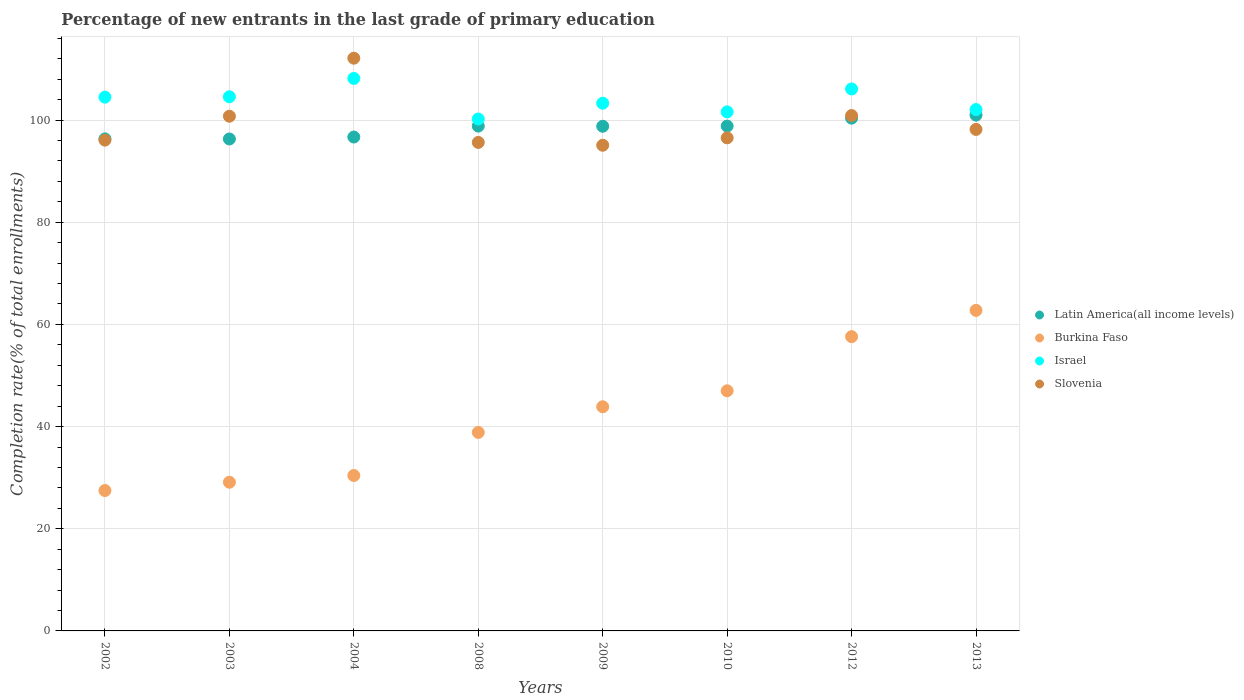Is the number of dotlines equal to the number of legend labels?
Your answer should be compact. Yes. What is the percentage of new entrants in Israel in 2009?
Provide a short and direct response. 103.29. Across all years, what is the maximum percentage of new entrants in Israel?
Provide a short and direct response. 108.15. Across all years, what is the minimum percentage of new entrants in Latin America(all income levels)?
Make the answer very short. 96.29. In which year was the percentage of new entrants in Israel maximum?
Provide a succinct answer. 2004. What is the total percentage of new entrants in Slovenia in the graph?
Give a very brief answer. 795.18. What is the difference between the percentage of new entrants in Latin America(all income levels) in 2009 and that in 2010?
Your answer should be compact. -0.04. What is the difference between the percentage of new entrants in Latin America(all income levels) in 2002 and the percentage of new entrants in Burkina Faso in 2003?
Offer a very short reply. 67.21. What is the average percentage of new entrants in Israel per year?
Provide a succinct answer. 103.8. In the year 2010, what is the difference between the percentage of new entrants in Slovenia and percentage of new entrants in Israel?
Offer a terse response. -5.08. What is the ratio of the percentage of new entrants in Israel in 2002 to that in 2003?
Offer a terse response. 1. Is the percentage of new entrants in Israel in 2002 less than that in 2003?
Provide a succinct answer. Yes. Is the difference between the percentage of new entrants in Slovenia in 2002 and 2004 greater than the difference between the percentage of new entrants in Israel in 2002 and 2004?
Give a very brief answer. No. What is the difference between the highest and the second highest percentage of new entrants in Burkina Faso?
Provide a short and direct response. 5.15. What is the difference between the highest and the lowest percentage of new entrants in Latin America(all income levels)?
Your answer should be compact. 4.67. In how many years, is the percentage of new entrants in Burkina Faso greater than the average percentage of new entrants in Burkina Faso taken over all years?
Make the answer very short. 4. Is the sum of the percentage of new entrants in Slovenia in 2004 and 2008 greater than the maximum percentage of new entrants in Latin America(all income levels) across all years?
Give a very brief answer. Yes. Is it the case that in every year, the sum of the percentage of new entrants in Slovenia and percentage of new entrants in Burkina Faso  is greater than the percentage of new entrants in Israel?
Provide a succinct answer. Yes. Does the percentage of new entrants in Israel monotonically increase over the years?
Offer a very short reply. No. What is the difference between two consecutive major ticks on the Y-axis?
Ensure brevity in your answer.  20. Are the values on the major ticks of Y-axis written in scientific E-notation?
Make the answer very short. No. Does the graph contain any zero values?
Offer a very short reply. No. Does the graph contain grids?
Your answer should be very brief. Yes. Where does the legend appear in the graph?
Give a very brief answer. Center right. What is the title of the graph?
Your answer should be compact. Percentage of new entrants in the last grade of primary education. What is the label or title of the X-axis?
Your response must be concise. Years. What is the label or title of the Y-axis?
Keep it short and to the point. Completion rate(% of total enrollments). What is the Completion rate(% of total enrollments) in Latin America(all income levels) in 2002?
Ensure brevity in your answer.  96.31. What is the Completion rate(% of total enrollments) of Burkina Faso in 2002?
Offer a very short reply. 27.48. What is the Completion rate(% of total enrollments) in Israel in 2002?
Your answer should be very brief. 104.48. What is the Completion rate(% of total enrollments) in Slovenia in 2002?
Your answer should be compact. 96.07. What is the Completion rate(% of total enrollments) in Latin America(all income levels) in 2003?
Your answer should be very brief. 96.29. What is the Completion rate(% of total enrollments) of Burkina Faso in 2003?
Keep it short and to the point. 29.11. What is the Completion rate(% of total enrollments) of Israel in 2003?
Your answer should be compact. 104.55. What is the Completion rate(% of total enrollments) in Slovenia in 2003?
Offer a very short reply. 100.75. What is the Completion rate(% of total enrollments) of Latin America(all income levels) in 2004?
Offer a very short reply. 96.68. What is the Completion rate(% of total enrollments) in Burkina Faso in 2004?
Ensure brevity in your answer.  30.42. What is the Completion rate(% of total enrollments) in Israel in 2004?
Provide a short and direct response. 108.15. What is the Completion rate(% of total enrollments) of Slovenia in 2004?
Your answer should be compact. 112.11. What is the Completion rate(% of total enrollments) in Latin America(all income levels) in 2008?
Offer a terse response. 98.81. What is the Completion rate(% of total enrollments) in Burkina Faso in 2008?
Give a very brief answer. 38.86. What is the Completion rate(% of total enrollments) in Israel in 2008?
Your answer should be very brief. 100.2. What is the Completion rate(% of total enrollments) of Slovenia in 2008?
Provide a succinct answer. 95.62. What is the Completion rate(% of total enrollments) in Latin America(all income levels) in 2009?
Ensure brevity in your answer.  98.78. What is the Completion rate(% of total enrollments) of Burkina Faso in 2009?
Ensure brevity in your answer.  43.88. What is the Completion rate(% of total enrollments) in Israel in 2009?
Your answer should be very brief. 103.29. What is the Completion rate(% of total enrollments) of Slovenia in 2009?
Provide a short and direct response. 95.07. What is the Completion rate(% of total enrollments) in Latin America(all income levels) in 2010?
Make the answer very short. 98.82. What is the Completion rate(% of total enrollments) of Burkina Faso in 2010?
Ensure brevity in your answer.  47. What is the Completion rate(% of total enrollments) in Israel in 2010?
Ensure brevity in your answer.  101.6. What is the Completion rate(% of total enrollments) in Slovenia in 2010?
Keep it short and to the point. 96.52. What is the Completion rate(% of total enrollments) of Latin America(all income levels) in 2012?
Provide a succinct answer. 100.37. What is the Completion rate(% of total enrollments) in Burkina Faso in 2012?
Keep it short and to the point. 57.6. What is the Completion rate(% of total enrollments) of Israel in 2012?
Your answer should be compact. 106.08. What is the Completion rate(% of total enrollments) of Slovenia in 2012?
Give a very brief answer. 100.88. What is the Completion rate(% of total enrollments) of Latin America(all income levels) in 2013?
Make the answer very short. 100.96. What is the Completion rate(% of total enrollments) in Burkina Faso in 2013?
Your answer should be compact. 62.75. What is the Completion rate(% of total enrollments) of Israel in 2013?
Ensure brevity in your answer.  102.05. What is the Completion rate(% of total enrollments) of Slovenia in 2013?
Your response must be concise. 98.17. Across all years, what is the maximum Completion rate(% of total enrollments) in Latin America(all income levels)?
Provide a short and direct response. 100.96. Across all years, what is the maximum Completion rate(% of total enrollments) in Burkina Faso?
Give a very brief answer. 62.75. Across all years, what is the maximum Completion rate(% of total enrollments) in Israel?
Provide a succinct answer. 108.15. Across all years, what is the maximum Completion rate(% of total enrollments) in Slovenia?
Offer a very short reply. 112.11. Across all years, what is the minimum Completion rate(% of total enrollments) of Latin America(all income levels)?
Your answer should be compact. 96.29. Across all years, what is the minimum Completion rate(% of total enrollments) of Burkina Faso?
Ensure brevity in your answer.  27.48. Across all years, what is the minimum Completion rate(% of total enrollments) of Israel?
Keep it short and to the point. 100.2. Across all years, what is the minimum Completion rate(% of total enrollments) of Slovenia?
Your answer should be compact. 95.07. What is the total Completion rate(% of total enrollments) of Latin America(all income levels) in the graph?
Provide a short and direct response. 787.03. What is the total Completion rate(% of total enrollments) of Burkina Faso in the graph?
Keep it short and to the point. 337.1. What is the total Completion rate(% of total enrollments) in Israel in the graph?
Give a very brief answer. 830.41. What is the total Completion rate(% of total enrollments) of Slovenia in the graph?
Your response must be concise. 795.18. What is the difference between the Completion rate(% of total enrollments) in Latin America(all income levels) in 2002 and that in 2003?
Your answer should be compact. 0.02. What is the difference between the Completion rate(% of total enrollments) in Burkina Faso in 2002 and that in 2003?
Make the answer very short. -1.62. What is the difference between the Completion rate(% of total enrollments) in Israel in 2002 and that in 2003?
Give a very brief answer. -0.07. What is the difference between the Completion rate(% of total enrollments) of Slovenia in 2002 and that in 2003?
Offer a very short reply. -4.68. What is the difference between the Completion rate(% of total enrollments) in Latin America(all income levels) in 2002 and that in 2004?
Provide a short and direct response. -0.36. What is the difference between the Completion rate(% of total enrollments) of Burkina Faso in 2002 and that in 2004?
Ensure brevity in your answer.  -2.94. What is the difference between the Completion rate(% of total enrollments) of Israel in 2002 and that in 2004?
Ensure brevity in your answer.  -3.66. What is the difference between the Completion rate(% of total enrollments) in Slovenia in 2002 and that in 2004?
Offer a very short reply. -16.04. What is the difference between the Completion rate(% of total enrollments) in Latin America(all income levels) in 2002 and that in 2008?
Ensure brevity in your answer.  -2.5. What is the difference between the Completion rate(% of total enrollments) of Burkina Faso in 2002 and that in 2008?
Your response must be concise. -11.38. What is the difference between the Completion rate(% of total enrollments) of Israel in 2002 and that in 2008?
Ensure brevity in your answer.  4.28. What is the difference between the Completion rate(% of total enrollments) in Slovenia in 2002 and that in 2008?
Your response must be concise. 0.45. What is the difference between the Completion rate(% of total enrollments) of Latin America(all income levels) in 2002 and that in 2009?
Keep it short and to the point. -2.47. What is the difference between the Completion rate(% of total enrollments) in Burkina Faso in 2002 and that in 2009?
Offer a very short reply. -16.4. What is the difference between the Completion rate(% of total enrollments) of Israel in 2002 and that in 2009?
Offer a very short reply. 1.19. What is the difference between the Completion rate(% of total enrollments) in Latin America(all income levels) in 2002 and that in 2010?
Your answer should be very brief. -2.51. What is the difference between the Completion rate(% of total enrollments) of Burkina Faso in 2002 and that in 2010?
Provide a succinct answer. -19.52. What is the difference between the Completion rate(% of total enrollments) of Israel in 2002 and that in 2010?
Your answer should be very brief. 2.89. What is the difference between the Completion rate(% of total enrollments) in Slovenia in 2002 and that in 2010?
Provide a short and direct response. -0.45. What is the difference between the Completion rate(% of total enrollments) in Latin America(all income levels) in 2002 and that in 2012?
Give a very brief answer. -4.06. What is the difference between the Completion rate(% of total enrollments) in Burkina Faso in 2002 and that in 2012?
Your answer should be compact. -30.12. What is the difference between the Completion rate(% of total enrollments) of Israel in 2002 and that in 2012?
Provide a succinct answer. -1.6. What is the difference between the Completion rate(% of total enrollments) in Slovenia in 2002 and that in 2012?
Offer a terse response. -4.81. What is the difference between the Completion rate(% of total enrollments) in Latin America(all income levels) in 2002 and that in 2013?
Offer a terse response. -4.65. What is the difference between the Completion rate(% of total enrollments) of Burkina Faso in 2002 and that in 2013?
Provide a short and direct response. -35.27. What is the difference between the Completion rate(% of total enrollments) in Israel in 2002 and that in 2013?
Offer a very short reply. 2.44. What is the difference between the Completion rate(% of total enrollments) in Slovenia in 2002 and that in 2013?
Make the answer very short. -2.1. What is the difference between the Completion rate(% of total enrollments) in Latin America(all income levels) in 2003 and that in 2004?
Keep it short and to the point. -0.38. What is the difference between the Completion rate(% of total enrollments) in Burkina Faso in 2003 and that in 2004?
Ensure brevity in your answer.  -1.31. What is the difference between the Completion rate(% of total enrollments) of Israel in 2003 and that in 2004?
Keep it short and to the point. -3.59. What is the difference between the Completion rate(% of total enrollments) in Slovenia in 2003 and that in 2004?
Keep it short and to the point. -11.36. What is the difference between the Completion rate(% of total enrollments) in Latin America(all income levels) in 2003 and that in 2008?
Provide a short and direct response. -2.52. What is the difference between the Completion rate(% of total enrollments) of Burkina Faso in 2003 and that in 2008?
Provide a short and direct response. -9.75. What is the difference between the Completion rate(% of total enrollments) of Israel in 2003 and that in 2008?
Provide a succinct answer. 4.35. What is the difference between the Completion rate(% of total enrollments) of Slovenia in 2003 and that in 2008?
Provide a succinct answer. 5.13. What is the difference between the Completion rate(% of total enrollments) of Latin America(all income levels) in 2003 and that in 2009?
Your answer should be very brief. -2.49. What is the difference between the Completion rate(% of total enrollments) of Burkina Faso in 2003 and that in 2009?
Provide a short and direct response. -14.77. What is the difference between the Completion rate(% of total enrollments) in Israel in 2003 and that in 2009?
Offer a very short reply. 1.26. What is the difference between the Completion rate(% of total enrollments) in Slovenia in 2003 and that in 2009?
Provide a succinct answer. 5.68. What is the difference between the Completion rate(% of total enrollments) of Latin America(all income levels) in 2003 and that in 2010?
Offer a very short reply. -2.52. What is the difference between the Completion rate(% of total enrollments) in Burkina Faso in 2003 and that in 2010?
Offer a terse response. -17.89. What is the difference between the Completion rate(% of total enrollments) of Israel in 2003 and that in 2010?
Keep it short and to the point. 2.96. What is the difference between the Completion rate(% of total enrollments) in Slovenia in 2003 and that in 2010?
Your response must be concise. 4.23. What is the difference between the Completion rate(% of total enrollments) in Latin America(all income levels) in 2003 and that in 2012?
Offer a very short reply. -4.08. What is the difference between the Completion rate(% of total enrollments) of Burkina Faso in 2003 and that in 2012?
Provide a short and direct response. -28.49. What is the difference between the Completion rate(% of total enrollments) of Israel in 2003 and that in 2012?
Make the answer very short. -1.53. What is the difference between the Completion rate(% of total enrollments) of Slovenia in 2003 and that in 2012?
Offer a terse response. -0.13. What is the difference between the Completion rate(% of total enrollments) of Latin America(all income levels) in 2003 and that in 2013?
Offer a terse response. -4.67. What is the difference between the Completion rate(% of total enrollments) of Burkina Faso in 2003 and that in 2013?
Give a very brief answer. -33.64. What is the difference between the Completion rate(% of total enrollments) of Israel in 2003 and that in 2013?
Keep it short and to the point. 2.51. What is the difference between the Completion rate(% of total enrollments) of Slovenia in 2003 and that in 2013?
Keep it short and to the point. 2.58. What is the difference between the Completion rate(% of total enrollments) in Latin America(all income levels) in 2004 and that in 2008?
Offer a very short reply. -2.14. What is the difference between the Completion rate(% of total enrollments) of Burkina Faso in 2004 and that in 2008?
Ensure brevity in your answer.  -8.44. What is the difference between the Completion rate(% of total enrollments) in Israel in 2004 and that in 2008?
Make the answer very short. 7.94. What is the difference between the Completion rate(% of total enrollments) in Slovenia in 2004 and that in 2008?
Provide a succinct answer. 16.49. What is the difference between the Completion rate(% of total enrollments) in Latin America(all income levels) in 2004 and that in 2009?
Your response must be concise. -2.11. What is the difference between the Completion rate(% of total enrollments) of Burkina Faso in 2004 and that in 2009?
Your answer should be very brief. -13.46. What is the difference between the Completion rate(% of total enrollments) of Israel in 2004 and that in 2009?
Offer a very short reply. 4.85. What is the difference between the Completion rate(% of total enrollments) of Slovenia in 2004 and that in 2009?
Your answer should be very brief. 17.04. What is the difference between the Completion rate(% of total enrollments) of Latin America(all income levels) in 2004 and that in 2010?
Offer a very short reply. -2.14. What is the difference between the Completion rate(% of total enrollments) of Burkina Faso in 2004 and that in 2010?
Give a very brief answer. -16.58. What is the difference between the Completion rate(% of total enrollments) of Israel in 2004 and that in 2010?
Provide a short and direct response. 6.55. What is the difference between the Completion rate(% of total enrollments) of Slovenia in 2004 and that in 2010?
Make the answer very short. 15.59. What is the difference between the Completion rate(% of total enrollments) in Latin America(all income levels) in 2004 and that in 2012?
Ensure brevity in your answer.  -3.7. What is the difference between the Completion rate(% of total enrollments) in Burkina Faso in 2004 and that in 2012?
Keep it short and to the point. -27.18. What is the difference between the Completion rate(% of total enrollments) of Israel in 2004 and that in 2012?
Provide a short and direct response. 2.06. What is the difference between the Completion rate(% of total enrollments) of Slovenia in 2004 and that in 2012?
Make the answer very short. 11.22. What is the difference between the Completion rate(% of total enrollments) in Latin America(all income levels) in 2004 and that in 2013?
Give a very brief answer. -4.29. What is the difference between the Completion rate(% of total enrollments) of Burkina Faso in 2004 and that in 2013?
Your answer should be compact. -32.33. What is the difference between the Completion rate(% of total enrollments) of Israel in 2004 and that in 2013?
Offer a terse response. 6.1. What is the difference between the Completion rate(% of total enrollments) in Slovenia in 2004 and that in 2013?
Your answer should be compact. 13.94. What is the difference between the Completion rate(% of total enrollments) of Latin America(all income levels) in 2008 and that in 2009?
Offer a very short reply. 0.03. What is the difference between the Completion rate(% of total enrollments) of Burkina Faso in 2008 and that in 2009?
Give a very brief answer. -5.02. What is the difference between the Completion rate(% of total enrollments) of Israel in 2008 and that in 2009?
Offer a terse response. -3.09. What is the difference between the Completion rate(% of total enrollments) in Slovenia in 2008 and that in 2009?
Make the answer very short. 0.55. What is the difference between the Completion rate(% of total enrollments) of Latin America(all income levels) in 2008 and that in 2010?
Your answer should be very brief. -0. What is the difference between the Completion rate(% of total enrollments) of Burkina Faso in 2008 and that in 2010?
Your answer should be very brief. -8.14. What is the difference between the Completion rate(% of total enrollments) in Israel in 2008 and that in 2010?
Your answer should be very brief. -1.39. What is the difference between the Completion rate(% of total enrollments) in Slovenia in 2008 and that in 2010?
Offer a very short reply. -0.89. What is the difference between the Completion rate(% of total enrollments) of Latin America(all income levels) in 2008 and that in 2012?
Make the answer very short. -1.56. What is the difference between the Completion rate(% of total enrollments) of Burkina Faso in 2008 and that in 2012?
Offer a very short reply. -18.74. What is the difference between the Completion rate(% of total enrollments) in Israel in 2008 and that in 2012?
Your response must be concise. -5.88. What is the difference between the Completion rate(% of total enrollments) of Slovenia in 2008 and that in 2012?
Your answer should be compact. -5.26. What is the difference between the Completion rate(% of total enrollments) of Latin America(all income levels) in 2008 and that in 2013?
Keep it short and to the point. -2.15. What is the difference between the Completion rate(% of total enrollments) of Burkina Faso in 2008 and that in 2013?
Offer a very short reply. -23.89. What is the difference between the Completion rate(% of total enrollments) of Israel in 2008 and that in 2013?
Offer a terse response. -1.84. What is the difference between the Completion rate(% of total enrollments) of Slovenia in 2008 and that in 2013?
Your answer should be very brief. -2.55. What is the difference between the Completion rate(% of total enrollments) in Latin America(all income levels) in 2009 and that in 2010?
Offer a terse response. -0.04. What is the difference between the Completion rate(% of total enrollments) in Burkina Faso in 2009 and that in 2010?
Offer a very short reply. -3.12. What is the difference between the Completion rate(% of total enrollments) in Israel in 2009 and that in 2010?
Your answer should be compact. 1.7. What is the difference between the Completion rate(% of total enrollments) in Slovenia in 2009 and that in 2010?
Give a very brief answer. -1.45. What is the difference between the Completion rate(% of total enrollments) of Latin America(all income levels) in 2009 and that in 2012?
Provide a succinct answer. -1.59. What is the difference between the Completion rate(% of total enrollments) in Burkina Faso in 2009 and that in 2012?
Keep it short and to the point. -13.72. What is the difference between the Completion rate(% of total enrollments) in Israel in 2009 and that in 2012?
Offer a terse response. -2.79. What is the difference between the Completion rate(% of total enrollments) of Slovenia in 2009 and that in 2012?
Your response must be concise. -5.81. What is the difference between the Completion rate(% of total enrollments) in Latin America(all income levels) in 2009 and that in 2013?
Ensure brevity in your answer.  -2.18. What is the difference between the Completion rate(% of total enrollments) of Burkina Faso in 2009 and that in 2013?
Your answer should be compact. -18.87. What is the difference between the Completion rate(% of total enrollments) of Israel in 2009 and that in 2013?
Your answer should be very brief. 1.25. What is the difference between the Completion rate(% of total enrollments) of Slovenia in 2009 and that in 2013?
Your response must be concise. -3.1. What is the difference between the Completion rate(% of total enrollments) in Latin America(all income levels) in 2010 and that in 2012?
Make the answer very short. -1.56. What is the difference between the Completion rate(% of total enrollments) of Israel in 2010 and that in 2012?
Offer a very short reply. -4.49. What is the difference between the Completion rate(% of total enrollments) of Slovenia in 2010 and that in 2012?
Provide a succinct answer. -4.37. What is the difference between the Completion rate(% of total enrollments) of Latin America(all income levels) in 2010 and that in 2013?
Your answer should be very brief. -2.14. What is the difference between the Completion rate(% of total enrollments) in Burkina Faso in 2010 and that in 2013?
Your answer should be very brief. -15.75. What is the difference between the Completion rate(% of total enrollments) of Israel in 2010 and that in 2013?
Your answer should be very brief. -0.45. What is the difference between the Completion rate(% of total enrollments) of Slovenia in 2010 and that in 2013?
Your answer should be compact. -1.65. What is the difference between the Completion rate(% of total enrollments) in Latin America(all income levels) in 2012 and that in 2013?
Your response must be concise. -0.59. What is the difference between the Completion rate(% of total enrollments) in Burkina Faso in 2012 and that in 2013?
Ensure brevity in your answer.  -5.15. What is the difference between the Completion rate(% of total enrollments) in Israel in 2012 and that in 2013?
Offer a terse response. 4.04. What is the difference between the Completion rate(% of total enrollments) of Slovenia in 2012 and that in 2013?
Your answer should be compact. 2.71. What is the difference between the Completion rate(% of total enrollments) of Latin America(all income levels) in 2002 and the Completion rate(% of total enrollments) of Burkina Faso in 2003?
Give a very brief answer. 67.21. What is the difference between the Completion rate(% of total enrollments) of Latin America(all income levels) in 2002 and the Completion rate(% of total enrollments) of Israel in 2003?
Ensure brevity in your answer.  -8.24. What is the difference between the Completion rate(% of total enrollments) of Latin America(all income levels) in 2002 and the Completion rate(% of total enrollments) of Slovenia in 2003?
Your answer should be very brief. -4.44. What is the difference between the Completion rate(% of total enrollments) of Burkina Faso in 2002 and the Completion rate(% of total enrollments) of Israel in 2003?
Offer a very short reply. -77.07. What is the difference between the Completion rate(% of total enrollments) in Burkina Faso in 2002 and the Completion rate(% of total enrollments) in Slovenia in 2003?
Keep it short and to the point. -73.26. What is the difference between the Completion rate(% of total enrollments) of Israel in 2002 and the Completion rate(% of total enrollments) of Slovenia in 2003?
Your answer should be very brief. 3.74. What is the difference between the Completion rate(% of total enrollments) in Latin America(all income levels) in 2002 and the Completion rate(% of total enrollments) in Burkina Faso in 2004?
Provide a succinct answer. 65.89. What is the difference between the Completion rate(% of total enrollments) in Latin America(all income levels) in 2002 and the Completion rate(% of total enrollments) in Israel in 2004?
Make the answer very short. -11.83. What is the difference between the Completion rate(% of total enrollments) in Latin America(all income levels) in 2002 and the Completion rate(% of total enrollments) in Slovenia in 2004?
Your answer should be compact. -15.79. What is the difference between the Completion rate(% of total enrollments) in Burkina Faso in 2002 and the Completion rate(% of total enrollments) in Israel in 2004?
Offer a very short reply. -80.66. What is the difference between the Completion rate(% of total enrollments) of Burkina Faso in 2002 and the Completion rate(% of total enrollments) of Slovenia in 2004?
Provide a succinct answer. -84.62. What is the difference between the Completion rate(% of total enrollments) of Israel in 2002 and the Completion rate(% of total enrollments) of Slovenia in 2004?
Provide a short and direct response. -7.62. What is the difference between the Completion rate(% of total enrollments) in Latin America(all income levels) in 2002 and the Completion rate(% of total enrollments) in Burkina Faso in 2008?
Your answer should be compact. 57.45. What is the difference between the Completion rate(% of total enrollments) of Latin America(all income levels) in 2002 and the Completion rate(% of total enrollments) of Israel in 2008?
Ensure brevity in your answer.  -3.89. What is the difference between the Completion rate(% of total enrollments) of Latin America(all income levels) in 2002 and the Completion rate(% of total enrollments) of Slovenia in 2008?
Your response must be concise. 0.69. What is the difference between the Completion rate(% of total enrollments) of Burkina Faso in 2002 and the Completion rate(% of total enrollments) of Israel in 2008?
Ensure brevity in your answer.  -72.72. What is the difference between the Completion rate(% of total enrollments) of Burkina Faso in 2002 and the Completion rate(% of total enrollments) of Slovenia in 2008?
Give a very brief answer. -68.14. What is the difference between the Completion rate(% of total enrollments) in Israel in 2002 and the Completion rate(% of total enrollments) in Slovenia in 2008?
Provide a short and direct response. 8.86. What is the difference between the Completion rate(% of total enrollments) of Latin America(all income levels) in 2002 and the Completion rate(% of total enrollments) of Burkina Faso in 2009?
Your response must be concise. 52.43. What is the difference between the Completion rate(% of total enrollments) in Latin America(all income levels) in 2002 and the Completion rate(% of total enrollments) in Israel in 2009?
Offer a terse response. -6.98. What is the difference between the Completion rate(% of total enrollments) in Latin America(all income levels) in 2002 and the Completion rate(% of total enrollments) in Slovenia in 2009?
Ensure brevity in your answer.  1.24. What is the difference between the Completion rate(% of total enrollments) of Burkina Faso in 2002 and the Completion rate(% of total enrollments) of Israel in 2009?
Offer a very short reply. -75.81. What is the difference between the Completion rate(% of total enrollments) in Burkina Faso in 2002 and the Completion rate(% of total enrollments) in Slovenia in 2009?
Ensure brevity in your answer.  -67.58. What is the difference between the Completion rate(% of total enrollments) of Israel in 2002 and the Completion rate(% of total enrollments) of Slovenia in 2009?
Provide a short and direct response. 9.42. What is the difference between the Completion rate(% of total enrollments) in Latin America(all income levels) in 2002 and the Completion rate(% of total enrollments) in Burkina Faso in 2010?
Keep it short and to the point. 49.31. What is the difference between the Completion rate(% of total enrollments) in Latin America(all income levels) in 2002 and the Completion rate(% of total enrollments) in Israel in 2010?
Provide a succinct answer. -5.28. What is the difference between the Completion rate(% of total enrollments) in Latin America(all income levels) in 2002 and the Completion rate(% of total enrollments) in Slovenia in 2010?
Provide a short and direct response. -0.2. What is the difference between the Completion rate(% of total enrollments) of Burkina Faso in 2002 and the Completion rate(% of total enrollments) of Israel in 2010?
Offer a very short reply. -74.11. What is the difference between the Completion rate(% of total enrollments) in Burkina Faso in 2002 and the Completion rate(% of total enrollments) in Slovenia in 2010?
Offer a terse response. -69.03. What is the difference between the Completion rate(% of total enrollments) in Israel in 2002 and the Completion rate(% of total enrollments) in Slovenia in 2010?
Your answer should be compact. 7.97. What is the difference between the Completion rate(% of total enrollments) of Latin America(all income levels) in 2002 and the Completion rate(% of total enrollments) of Burkina Faso in 2012?
Your answer should be compact. 38.71. What is the difference between the Completion rate(% of total enrollments) in Latin America(all income levels) in 2002 and the Completion rate(% of total enrollments) in Israel in 2012?
Keep it short and to the point. -9.77. What is the difference between the Completion rate(% of total enrollments) in Latin America(all income levels) in 2002 and the Completion rate(% of total enrollments) in Slovenia in 2012?
Provide a short and direct response. -4.57. What is the difference between the Completion rate(% of total enrollments) in Burkina Faso in 2002 and the Completion rate(% of total enrollments) in Israel in 2012?
Offer a terse response. -78.6. What is the difference between the Completion rate(% of total enrollments) of Burkina Faso in 2002 and the Completion rate(% of total enrollments) of Slovenia in 2012?
Keep it short and to the point. -73.4. What is the difference between the Completion rate(% of total enrollments) in Israel in 2002 and the Completion rate(% of total enrollments) in Slovenia in 2012?
Your response must be concise. 3.6. What is the difference between the Completion rate(% of total enrollments) of Latin America(all income levels) in 2002 and the Completion rate(% of total enrollments) of Burkina Faso in 2013?
Make the answer very short. 33.56. What is the difference between the Completion rate(% of total enrollments) in Latin America(all income levels) in 2002 and the Completion rate(% of total enrollments) in Israel in 2013?
Your answer should be compact. -5.73. What is the difference between the Completion rate(% of total enrollments) of Latin America(all income levels) in 2002 and the Completion rate(% of total enrollments) of Slovenia in 2013?
Ensure brevity in your answer.  -1.86. What is the difference between the Completion rate(% of total enrollments) of Burkina Faso in 2002 and the Completion rate(% of total enrollments) of Israel in 2013?
Offer a terse response. -74.56. What is the difference between the Completion rate(% of total enrollments) of Burkina Faso in 2002 and the Completion rate(% of total enrollments) of Slovenia in 2013?
Your answer should be very brief. -70.69. What is the difference between the Completion rate(% of total enrollments) in Israel in 2002 and the Completion rate(% of total enrollments) in Slovenia in 2013?
Your answer should be very brief. 6.32. What is the difference between the Completion rate(% of total enrollments) in Latin America(all income levels) in 2003 and the Completion rate(% of total enrollments) in Burkina Faso in 2004?
Provide a short and direct response. 65.87. What is the difference between the Completion rate(% of total enrollments) of Latin America(all income levels) in 2003 and the Completion rate(% of total enrollments) of Israel in 2004?
Your answer should be very brief. -11.85. What is the difference between the Completion rate(% of total enrollments) in Latin America(all income levels) in 2003 and the Completion rate(% of total enrollments) in Slovenia in 2004?
Provide a succinct answer. -15.81. What is the difference between the Completion rate(% of total enrollments) in Burkina Faso in 2003 and the Completion rate(% of total enrollments) in Israel in 2004?
Your response must be concise. -79.04. What is the difference between the Completion rate(% of total enrollments) of Burkina Faso in 2003 and the Completion rate(% of total enrollments) of Slovenia in 2004?
Provide a succinct answer. -83. What is the difference between the Completion rate(% of total enrollments) of Israel in 2003 and the Completion rate(% of total enrollments) of Slovenia in 2004?
Your answer should be very brief. -7.55. What is the difference between the Completion rate(% of total enrollments) of Latin America(all income levels) in 2003 and the Completion rate(% of total enrollments) of Burkina Faso in 2008?
Give a very brief answer. 57.44. What is the difference between the Completion rate(% of total enrollments) in Latin America(all income levels) in 2003 and the Completion rate(% of total enrollments) in Israel in 2008?
Offer a terse response. -3.91. What is the difference between the Completion rate(% of total enrollments) of Latin America(all income levels) in 2003 and the Completion rate(% of total enrollments) of Slovenia in 2008?
Make the answer very short. 0.67. What is the difference between the Completion rate(% of total enrollments) of Burkina Faso in 2003 and the Completion rate(% of total enrollments) of Israel in 2008?
Offer a terse response. -71.1. What is the difference between the Completion rate(% of total enrollments) in Burkina Faso in 2003 and the Completion rate(% of total enrollments) in Slovenia in 2008?
Keep it short and to the point. -66.51. What is the difference between the Completion rate(% of total enrollments) of Israel in 2003 and the Completion rate(% of total enrollments) of Slovenia in 2008?
Provide a succinct answer. 8.93. What is the difference between the Completion rate(% of total enrollments) of Latin America(all income levels) in 2003 and the Completion rate(% of total enrollments) of Burkina Faso in 2009?
Your answer should be very brief. 52.41. What is the difference between the Completion rate(% of total enrollments) of Latin America(all income levels) in 2003 and the Completion rate(% of total enrollments) of Israel in 2009?
Your answer should be compact. -7. What is the difference between the Completion rate(% of total enrollments) of Latin America(all income levels) in 2003 and the Completion rate(% of total enrollments) of Slovenia in 2009?
Offer a terse response. 1.23. What is the difference between the Completion rate(% of total enrollments) in Burkina Faso in 2003 and the Completion rate(% of total enrollments) in Israel in 2009?
Keep it short and to the point. -74.19. What is the difference between the Completion rate(% of total enrollments) in Burkina Faso in 2003 and the Completion rate(% of total enrollments) in Slovenia in 2009?
Provide a short and direct response. -65.96. What is the difference between the Completion rate(% of total enrollments) in Israel in 2003 and the Completion rate(% of total enrollments) in Slovenia in 2009?
Give a very brief answer. 9.49. What is the difference between the Completion rate(% of total enrollments) in Latin America(all income levels) in 2003 and the Completion rate(% of total enrollments) in Burkina Faso in 2010?
Offer a very short reply. 49.29. What is the difference between the Completion rate(% of total enrollments) of Latin America(all income levels) in 2003 and the Completion rate(% of total enrollments) of Israel in 2010?
Keep it short and to the point. -5.3. What is the difference between the Completion rate(% of total enrollments) of Latin America(all income levels) in 2003 and the Completion rate(% of total enrollments) of Slovenia in 2010?
Give a very brief answer. -0.22. What is the difference between the Completion rate(% of total enrollments) of Burkina Faso in 2003 and the Completion rate(% of total enrollments) of Israel in 2010?
Give a very brief answer. -72.49. What is the difference between the Completion rate(% of total enrollments) in Burkina Faso in 2003 and the Completion rate(% of total enrollments) in Slovenia in 2010?
Your answer should be compact. -67.41. What is the difference between the Completion rate(% of total enrollments) in Israel in 2003 and the Completion rate(% of total enrollments) in Slovenia in 2010?
Give a very brief answer. 8.04. What is the difference between the Completion rate(% of total enrollments) of Latin America(all income levels) in 2003 and the Completion rate(% of total enrollments) of Burkina Faso in 2012?
Give a very brief answer. 38.69. What is the difference between the Completion rate(% of total enrollments) of Latin America(all income levels) in 2003 and the Completion rate(% of total enrollments) of Israel in 2012?
Make the answer very short. -9.79. What is the difference between the Completion rate(% of total enrollments) of Latin America(all income levels) in 2003 and the Completion rate(% of total enrollments) of Slovenia in 2012?
Give a very brief answer. -4.59. What is the difference between the Completion rate(% of total enrollments) in Burkina Faso in 2003 and the Completion rate(% of total enrollments) in Israel in 2012?
Provide a short and direct response. -76.98. What is the difference between the Completion rate(% of total enrollments) of Burkina Faso in 2003 and the Completion rate(% of total enrollments) of Slovenia in 2012?
Your answer should be compact. -71.78. What is the difference between the Completion rate(% of total enrollments) in Israel in 2003 and the Completion rate(% of total enrollments) in Slovenia in 2012?
Provide a short and direct response. 3.67. What is the difference between the Completion rate(% of total enrollments) in Latin America(all income levels) in 2003 and the Completion rate(% of total enrollments) in Burkina Faso in 2013?
Provide a succinct answer. 33.55. What is the difference between the Completion rate(% of total enrollments) of Latin America(all income levels) in 2003 and the Completion rate(% of total enrollments) of Israel in 2013?
Keep it short and to the point. -5.75. What is the difference between the Completion rate(% of total enrollments) of Latin America(all income levels) in 2003 and the Completion rate(% of total enrollments) of Slovenia in 2013?
Keep it short and to the point. -1.88. What is the difference between the Completion rate(% of total enrollments) in Burkina Faso in 2003 and the Completion rate(% of total enrollments) in Israel in 2013?
Offer a terse response. -72.94. What is the difference between the Completion rate(% of total enrollments) in Burkina Faso in 2003 and the Completion rate(% of total enrollments) in Slovenia in 2013?
Provide a short and direct response. -69.06. What is the difference between the Completion rate(% of total enrollments) in Israel in 2003 and the Completion rate(% of total enrollments) in Slovenia in 2013?
Provide a short and direct response. 6.39. What is the difference between the Completion rate(% of total enrollments) in Latin America(all income levels) in 2004 and the Completion rate(% of total enrollments) in Burkina Faso in 2008?
Your response must be concise. 57.82. What is the difference between the Completion rate(% of total enrollments) of Latin America(all income levels) in 2004 and the Completion rate(% of total enrollments) of Israel in 2008?
Offer a very short reply. -3.53. What is the difference between the Completion rate(% of total enrollments) of Latin America(all income levels) in 2004 and the Completion rate(% of total enrollments) of Slovenia in 2008?
Make the answer very short. 1.05. What is the difference between the Completion rate(% of total enrollments) in Burkina Faso in 2004 and the Completion rate(% of total enrollments) in Israel in 2008?
Make the answer very short. -69.78. What is the difference between the Completion rate(% of total enrollments) of Burkina Faso in 2004 and the Completion rate(% of total enrollments) of Slovenia in 2008?
Your response must be concise. -65.2. What is the difference between the Completion rate(% of total enrollments) of Israel in 2004 and the Completion rate(% of total enrollments) of Slovenia in 2008?
Offer a terse response. 12.52. What is the difference between the Completion rate(% of total enrollments) in Latin America(all income levels) in 2004 and the Completion rate(% of total enrollments) in Burkina Faso in 2009?
Make the answer very short. 52.8. What is the difference between the Completion rate(% of total enrollments) in Latin America(all income levels) in 2004 and the Completion rate(% of total enrollments) in Israel in 2009?
Make the answer very short. -6.62. What is the difference between the Completion rate(% of total enrollments) of Latin America(all income levels) in 2004 and the Completion rate(% of total enrollments) of Slovenia in 2009?
Make the answer very short. 1.61. What is the difference between the Completion rate(% of total enrollments) in Burkina Faso in 2004 and the Completion rate(% of total enrollments) in Israel in 2009?
Give a very brief answer. -72.87. What is the difference between the Completion rate(% of total enrollments) in Burkina Faso in 2004 and the Completion rate(% of total enrollments) in Slovenia in 2009?
Provide a succinct answer. -64.65. What is the difference between the Completion rate(% of total enrollments) in Israel in 2004 and the Completion rate(% of total enrollments) in Slovenia in 2009?
Give a very brief answer. 13.08. What is the difference between the Completion rate(% of total enrollments) of Latin America(all income levels) in 2004 and the Completion rate(% of total enrollments) of Burkina Faso in 2010?
Ensure brevity in your answer.  49.67. What is the difference between the Completion rate(% of total enrollments) in Latin America(all income levels) in 2004 and the Completion rate(% of total enrollments) in Israel in 2010?
Give a very brief answer. -4.92. What is the difference between the Completion rate(% of total enrollments) in Latin America(all income levels) in 2004 and the Completion rate(% of total enrollments) in Slovenia in 2010?
Your answer should be very brief. 0.16. What is the difference between the Completion rate(% of total enrollments) of Burkina Faso in 2004 and the Completion rate(% of total enrollments) of Israel in 2010?
Ensure brevity in your answer.  -71.18. What is the difference between the Completion rate(% of total enrollments) in Burkina Faso in 2004 and the Completion rate(% of total enrollments) in Slovenia in 2010?
Provide a succinct answer. -66.09. What is the difference between the Completion rate(% of total enrollments) of Israel in 2004 and the Completion rate(% of total enrollments) of Slovenia in 2010?
Ensure brevity in your answer.  11.63. What is the difference between the Completion rate(% of total enrollments) in Latin America(all income levels) in 2004 and the Completion rate(% of total enrollments) in Burkina Faso in 2012?
Give a very brief answer. 39.07. What is the difference between the Completion rate(% of total enrollments) in Latin America(all income levels) in 2004 and the Completion rate(% of total enrollments) in Israel in 2012?
Offer a terse response. -9.41. What is the difference between the Completion rate(% of total enrollments) in Latin America(all income levels) in 2004 and the Completion rate(% of total enrollments) in Slovenia in 2012?
Offer a very short reply. -4.21. What is the difference between the Completion rate(% of total enrollments) in Burkina Faso in 2004 and the Completion rate(% of total enrollments) in Israel in 2012?
Your answer should be compact. -75.66. What is the difference between the Completion rate(% of total enrollments) in Burkina Faso in 2004 and the Completion rate(% of total enrollments) in Slovenia in 2012?
Provide a succinct answer. -70.46. What is the difference between the Completion rate(% of total enrollments) of Israel in 2004 and the Completion rate(% of total enrollments) of Slovenia in 2012?
Provide a succinct answer. 7.26. What is the difference between the Completion rate(% of total enrollments) in Latin America(all income levels) in 2004 and the Completion rate(% of total enrollments) in Burkina Faso in 2013?
Keep it short and to the point. 33.93. What is the difference between the Completion rate(% of total enrollments) of Latin America(all income levels) in 2004 and the Completion rate(% of total enrollments) of Israel in 2013?
Offer a terse response. -5.37. What is the difference between the Completion rate(% of total enrollments) of Latin America(all income levels) in 2004 and the Completion rate(% of total enrollments) of Slovenia in 2013?
Offer a very short reply. -1.49. What is the difference between the Completion rate(% of total enrollments) of Burkina Faso in 2004 and the Completion rate(% of total enrollments) of Israel in 2013?
Give a very brief answer. -71.63. What is the difference between the Completion rate(% of total enrollments) of Burkina Faso in 2004 and the Completion rate(% of total enrollments) of Slovenia in 2013?
Ensure brevity in your answer.  -67.75. What is the difference between the Completion rate(% of total enrollments) in Israel in 2004 and the Completion rate(% of total enrollments) in Slovenia in 2013?
Give a very brief answer. 9.98. What is the difference between the Completion rate(% of total enrollments) of Latin America(all income levels) in 2008 and the Completion rate(% of total enrollments) of Burkina Faso in 2009?
Your response must be concise. 54.93. What is the difference between the Completion rate(% of total enrollments) in Latin America(all income levels) in 2008 and the Completion rate(% of total enrollments) in Israel in 2009?
Keep it short and to the point. -4.48. What is the difference between the Completion rate(% of total enrollments) in Latin America(all income levels) in 2008 and the Completion rate(% of total enrollments) in Slovenia in 2009?
Make the answer very short. 3.75. What is the difference between the Completion rate(% of total enrollments) in Burkina Faso in 2008 and the Completion rate(% of total enrollments) in Israel in 2009?
Give a very brief answer. -64.43. What is the difference between the Completion rate(% of total enrollments) of Burkina Faso in 2008 and the Completion rate(% of total enrollments) of Slovenia in 2009?
Your answer should be very brief. -56.21. What is the difference between the Completion rate(% of total enrollments) in Israel in 2008 and the Completion rate(% of total enrollments) in Slovenia in 2009?
Offer a terse response. 5.14. What is the difference between the Completion rate(% of total enrollments) in Latin America(all income levels) in 2008 and the Completion rate(% of total enrollments) in Burkina Faso in 2010?
Provide a succinct answer. 51.81. What is the difference between the Completion rate(% of total enrollments) of Latin America(all income levels) in 2008 and the Completion rate(% of total enrollments) of Israel in 2010?
Offer a terse response. -2.78. What is the difference between the Completion rate(% of total enrollments) of Latin America(all income levels) in 2008 and the Completion rate(% of total enrollments) of Slovenia in 2010?
Your answer should be very brief. 2.3. What is the difference between the Completion rate(% of total enrollments) in Burkina Faso in 2008 and the Completion rate(% of total enrollments) in Israel in 2010?
Ensure brevity in your answer.  -62.74. What is the difference between the Completion rate(% of total enrollments) in Burkina Faso in 2008 and the Completion rate(% of total enrollments) in Slovenia in 2010?
Your answer should be very brief. -57.66. What is the difference between the Completion rate(% of total enrollments) in Israel in 2008 and the Completion rate(% of total enrollments) in Slovenia in 2010?
Ensure brevity in your answer.  3.69. What is the difference between the Completion rate(% of total enrollments) of Latin America(all income levels) in 2008 and the Completion rate(% of total enrollments) of Burkina Faso in 2012?
Provide a short and direct response. 41.21. What is the difference between the Completion rate(% of total enrollments) in Latin America(all income levels) in 2008 and the Completion rate(% of total enrollments) in Israel in 2012?
Offer a very short reply. -7.27. What is the difference between the Completion rate(% of total enrollments) of Latin America(all income levels) in 2008 and the Completion rate(% of total enrollments) of Slovenia in 2012?
Provide a succinct answer. -2.07. What is the difference between the Completion rate(% of total enrollments) of Burkina Faso in 2008 and the Completion rate(% of total enrollments) of Israel in 2012?
Your response must be concise. -67.23. What is the difference between the Completion rate(% of total enrollments) of Burkina Faso in 2008 and the Completion rate(% of total enrollments) of Slovenia in 2012?
Keep it short and to the point. -62.02. What is the difference between the Completion rate(% of total enrollments) of Israel in 2008 and the Completion rate(% of total enrollments) of Slovenia in 2012?
Keep it short and to the point. -0.68. What is the difference between the Completion rate(% of total enrollments) of Latin America(all income levels) in 2008 and the Completion rate(% of total enrollments) of Burkina Faso in 2013?
Make the answer very short. 36.07. What is the difference between the Completion rate(% of total enrollments) in Latin America(all income levels) in 2008 and the Completion rate(% of total enrollments) in Israel in 2013?
Provide a succinct answer. -3.23. What is the difference between the Completion rate(% of total enrollments) of Latin America(all income levels) in 2008 and the Completion rate(% of total enrollments) of Slovenia in 2013?
Give a very brief answer. 0.65. What is the difference between the Completion rate(% of total enrollments) in Burkina Faso in 2008 and the Completion rate(% of total enrollments) in Israel in 2013?
Your response must be concise. -63.19. What is the difference between the Completion rate(% of total enrollments) in Burkina Faso in 2008 and the Completion rate(% of total enrollments) in Slovenia in 2013?
Your answer should be very brief. -59.31. What is the difference between the Completion rate(% of total enrollments) in Israel in 2008 and the Completion rate(% of total enrollments) in Slovenia in 2013?
Offer a very short reply. 2.03. What is the difference between the Completion rate(% of total enrollments) of Latin America(all income levels) in 2009 and the Completion rate(% of total enrollments) of Burkina Faso in 2010?
Keep it short and to the point. 51.78. What is the difference between the Completion rate(% of total enrollments) in Latin America(all income levels) in 2009 and the Completion rate(% of total enrollments) in Israel in 2010?
Offer a terse response. -2.82. What is the difference between the Completion rate(% of total enrollments) of Latin America(all income levels) in 2009 and the Completion rate(% of total enrollments) of Slovenia in 2010?
Give a very brief answer. 2.27. What is the difference between the Completion rate(% of total enrollments) of Burkina Faso in 2009 and the Completion rate(% of total enrollments) of Israel in 2010?
Provide a succinct answer. -57.72. What is the difference between the Completion rate(% of total enrollments) in Burkina Faso in 2009 and the Completion rate(% of total enrollments) in Slovenia in 2010?
Offer a very short reply. -52.64. What is the difference between the Completion rate(% of total enrollments) in Israel in 2009 and the Completion rate(% of total enrollments) in Slovenia in 2010?
Offer a terse response. 6.78. What is the difference between the Completion rate(% of total enrollments) in Latin America(all income levels) in 2009 and the Completion rate(% of total enrollments) in Burkina Faso in 2012?
Keep it short and to the point. 41.18. What is the difference between the Completion rate(% of total enrollments) in Latin America(all income levels) in 2009 and the Completion rate(% of total enrollments) in Israel in 2012?
Provide a short and direct response. -7.3. What is the difference between the Completion rate(% of total enrollments) in Latin America(all income levels) in 2009 and the Completion rate(% of total enrollments) in Slovenia in 2012?
Your answer should be compact. -2.1. What is the difference between the Completion rate(% of total enrollments) of Burkina Faso in 2009 and the Completion rate(% of total enrollments) of Israel in 2012?
Your answer should be compact. -62.2. What is the difference between the Completion rate(% of total enrollments) of Burkina Faso in 2009 and the Completion rate(% of total enrollments) of Slovenia in 2012?
Provide a short and direct response. -57. What is the difference between the Completion rate(% of total enrollments) of Israel in 2009 and the Completion rate(% of total enrollments) of Slovenia in 2012?
Make the answer very short. 2.41. What is the difference between the Completion rate(% of total enrollments) in Latin America(all income levels) in 2009 and the Completion rate(% of total enrollments) in Burkina Faso in 2013?
Provide a short and direct response. 36.03. What is the difference between the Completion rate(% of total enrollments) of Latin America(all income levels) in 2009 and the Completion rate(% of total enrollments) of Israel in 2013?
Offer a terse response. -3.26. What is the difference between the Completion rate(% of total enrollments) of Latin America(all income levels) in 2009 and the Completion rate(% of total enrollments) of Slovenia in 2013?
Offer a very short reply. 0.61. What is the difference between the Completion rate(% of total enrollments) of Burkina Faso in 2009 and the Completion rate(% of total enrollments) of Israel in 2013?
Your answer should be very brief. -58.17. What is the difference between the Completion rate(% of total enrollments) in Burkina Faso in 2009 and the Completion rate(% of total enrollments) in Slovenia in 2013?
Your answer should be very brief. -54.29. What is the difference between the Completion rate(% of total enrollments) of Israel in 2009 and the Completion rate(% of total enrollments) of Slovenia in 2013?
Your answer should be very brief. 5.12. What is the difference between the Completion rate(% of total enrollments) in Latin America(all income levels) in 2010 and the Completion rate(% of total enrollments) in Burkina Faso in 2012?
Offer a terse response. 41.22. What is the difference between the Completion rate(% of total enrollments) of Latin America(all income levels) in 2010 and the Completion rate(% of total enrollments) of Israel in 2012?
Offer a terse response. -7.27. What is the difference between the Completion rate(% of total enrollments) of Latin America(all income levels) in 2010 and the Completion rate(% of total enrollments) of Slovenia in 2012?
Offer a terse response. -2.06. What is the difference between the Completion rate(% of total enrollments) of Burkina Faso in 2010 and the Completion rate(% of total enrollments) of Israel in 2012?
Offer a very short reply. -59.08. What is the difference between the Completion rate(% of total enrollments) of Burkina Faso in 2010 and the Completion rate(% of total enrollments) of Slovenia in 2012?
Your answer should be very brief. -53.88. What is the difference between the Completion rate(% of total enrollments) in Israel in 2010 and the Completion rate(% of total enrollments) in Slovenia in 2012?
Offer a very short reply. 0.71. What is the difference between the Completion rate(% of total enrollments) of Latin America(all income levels) in 2010 and the Completion rate(% of total enrollments) of Burkina Faso in 2013?
Provide a succinct answer. 36.07. What is the difference between the Completion rate(% of total enrollments) in Latin America(all income levels) in 2010 and the Completion rate(% of total enrollments) in Israel in 2013?
Make the answer very short. -3.23. What is the difference between the Completion rate(% of total enrollments) in Latin America(all income levels) in 2010 and the Completion rate(% of total enrollments) in Slovenia in 2013?
Your response must be concise. 0.65. What is the difference between the Completion rate(% of total enrollments) in Burkina Faso in 2010 and the Completion rate(% of total enrollments) in Israel in 2013?
Ensure brevity in your answer.  -55.05. What is the difference between the Completion rate(% of total enrollments) of Burkina Faso in 2010 and the Completion rate(% of total enrollments) of Slovenia in 2013?
Your response must be concise. -51.17. What is the difference between the Completion rate(% of total enrollments) in Israel in 2010 and the Completion rate(% of total enrollments) in Slovenia in 2013?
Your answer should be compact. 3.43. What is the difference between the Completion rate(% of total enrollments) of Latin America(all income levels) in 2012 and the Completion rate(% of total enrollments) of Burkina Faso in 2013?
Your answer should be compact. 37.63. What is the difference between the Completion rate(% of total enrollments) in Latin America(all income levels) in 2012 and the Completion rate(% of total enrollments) in Israel in 2013?
Give a very brief answer. -1.67. What is the difference between the Completion rate(% of total enrollments) of Latin America(all income levels) in 2012 and the Completion rate(% of total enrollments) of Slovenia in 2013?
Provide a succinct answer. 2.21. What is the difference between the Completion rate(% of total enrollments) in Burkina Faso in 2012 and the Completion rate(% of total enrollments) in Israel in 2013?
Your answer should be compact. -44.45. What is the difference between the Completion rate(% of total enrollments) in Burkina Faso in 2012 and the Completion rate(% of total enrollments) in Slovenia in 2013?
Your answer should be very brief. -40.57. What is the difference between the Completion rate(% of total enrollments) in Israel in 2012 and the Completion rate(% of total enrollments) in Slovenia in 2013?
Give a very brief answer. 7.92. What is the average Completion rate(% of total enrollments) in Latin America(all income levels) per year?
Your response must be concise. 98.38. What is the average Completion rate(% of total enrollments) of Burkina Faso per year?
Your answer should be compact. 42.14. What is the average Completion rate(% of total enrollments) in Israel per year?
Your answer should be very brief. 103.8. What is the average Completion rate(% of total enrollments) of Slovenia per year?
Provide a short and direct response. 99.4. In the year 2002, what is the difference between the Completion rate(% of total enrollments) of Latin America(all income levels) and Completion rate(% of total enrollments) of Burkina Faso?
Give a very brief answer. 68.83. In the year 2002, what is the difference between the Completion rate(% of total enrollments) in Latin America(all income levels) and Completion rate(% of total enrollments) in Israel?
Keep it short and to the point. -8.17. In the year 2002, what is the difference between the Completion rate(% of total enrollments) in Latin America(all income levels) and Completion rate(% of total enrollments) in Slovenia?
Your answer should be very brief. 0.24. In the year 2002, what is the difference between the Completion rate(% of total enrollments) of Burkina Faso and Completion rate(% of total enrollments) of Israel?
Ensure brevity in your answer.  -77. In the year 2002, what is the difference between the Completion rate(% of total enrollments) in Burkina Faso and Completion rate(% of total enrollments) in Slovenia?
Your response must be concise. -68.59. In the year 2002, what is the difference between the Completion rate(% of total enrollments) of Israel and Completion rate(% of total enrollments) of Slovenia?
Offer a very short reply. 8.42. In the year 2003, what is the difference between the Completion rate(% of total enrollments) of Latin America(all income levels) and Completion rate(% of total enrollments) of Burkina Faso?
Offer a terse response. 67.19. In the year 2003, what is the difference between the Completion rate(% of total enrollments) in Latin America(all income levels) and Completion rate(% of total enrollments) in Israel?
Make the answer very short. -8.26. In the year 2003, what is the difference between the Completion rate(% of total enrollments) of Latin America(all income levels) and Completion rate(% of total enrollments) of Slovenia?
Ensure brevity in your answer.  -4.45. In the year 2003, what is the difference between the Completion rate(% of total enrollments) in Burkina Faso and Completion rate(% of total enrollments) in Israel?
Offer a very short reply. -75.45. In the year 2003, what is the difference between the Completion rate(% of total enrollments) in Burkina Faso and Completion rate(% of total enrollments) in Slovenia?
Give a very brief answer. -71.64. In the year 2003, what is the difference between the Completion rate(% of total enrollments) of Israel and Completion rate(% of total enrollments) of Slovenia?
Your response must be concise. 3.81. In the year 2004, what is the difference between the Completion rate(% of total enrollments) of Latin America(all income levels) and Completion rate(% of total enrollments) of Burkina Faso?
Offer a very short reply. 66.25. In the year 2004, what is the difference between the Completion rate(% of total enrollments) of Latin America(all income levels) and Completion rate(% of total enrollments) of Israel?
Give a very brief answer. -11.47. In the year 2004, what is the difference between the Completion rate(% of total enrollments) in Latin America(all income levels) and Completion rate(% of total enrollments) in Slovenia?
Your response must be concise. -15.43. In the year 2004, what is the difference between the Completion rate(% of total enrollments) in Burkina Faso and Completion rate(% of total enrollments) in Israel?
Give a very brief answer. -77.72. In the year 2004, what is the difference between the Completion rate(% of total enrollments) of Burkina Faso and Completion rate(% of total enrollments) of Slovenia?
Your answer should be compact. -81.69. In the year 2004, what is the difference between the Completion rate(% of total enrollments) in Israel and Completion rate(% of total enrollments) in Slovenia?
Ensure brevity in your answer.  -3.96. In the year 2008, what is the difference between the Completion rate(% of total enrollments) of Latin America(all income levels) and Completion rate(% of total enrollments) of Burkina Faso?
Provide a succinct answer. 59.96. In the year 2008, what is the difference between the Completion rate(% of total enrollments) of Latin America(all income levels) and Completion rate(% of total enrollments) of Israel?
Offer a very short reply. -1.39. In the year 2008, what is the difference between the Completion rate(% of total enrollments) in Latin America(all income levels) and Completion rate(% of total enrollments) in Slovenia?
Ensure brevity in your answer.  3.19. In the year 2008, what is the difference between the Completion rate(% of total enrollments) in Burkina Faso and Completion rate(% of total enrollments) in Israel?
Give a very brief answer. -61.34. In the year 2008, what is the difference between the Completion rate(% of total enrollments) in Burkina Faso and Completion rate(% of total enrollments) in Slovenia?
Provide a succinct answer. -56.76. In the year 2008, what is the difference between the Completion rate(% of total enrollments) in Israel and Completion rate(% of total enrollments) in Slovenia?
Keep it short and to the point. 4.58. In the year 2009, what is the difference between the Completion rate(% of total enrollments) of Latin America(all income levels) and Completion rate(% of total enrollments) of Burkina Faso?
Your answer should be compact. 54.9. In the year 2009, what is the difference between the Completion rate(% of total enrollments) of Latin America(all income levels) and Completion rate(% of total enrollments) of Israel?
Keep it short and to the point. -4.51. In the year 2009, what is the difference between the Completion rate(% of total enrollments) of Latin America(all income levels) and Completion rate(% of total enrollments) of Slovenia?
Your answer should be compact. 3.71. In the year 2009, what is the difference between the Completion rate(% of total enrollments) of Burkina Faso and Completion rate(% of total enrollments) of Israel?
Make the answer very short. -59.41. In the year 2009, what is the difference between the Completion rate(% of total enrollments) of Burkina Faso and Completion rate(% of total enrollments) of Slovenia?
Your response must be concise. -51.19. In the year 2009, what is the difference between the Completion rate(% of total enrollments) of Israel and Completion rate(% of total enrollments) of Slovenia?
Make the answer very short. 8.22. In the year 2010, what is the difference between the Completion rate(% of total enrollments) of Latin America(all income levels) and Completion rate(% of total enrollments) of Burkina Faso?
Your answer should be compact. 51.82. In the year 2010, what is the difference between the Completion rate(% of total enrollments) in Latin America(all income levels) and Completion rate(% of total enrollments) in Israel?
Provide a short and direct response. -2.78. In the year 2010, what is the difference between the Completion rate(% of total enrollments) of Latin America(all income levels) and Completion rate(% of total enrollments) of Slovenia?
Give a very brief answer. 2.3. In the year 2010, what is the difference between the Completion rate(% of total enrollments) in Burkina Faso and Completion rate(% of total enrollments) in Israel?
Your response must be concise. -54.6. In the year 2010, what is the difference between the Completion rate(% of total enrollments) of Burkina Faso and Completion rate(% of total enrollments) of Slovenia?
Make the answer very short. -49.51. In the year 2010, what is the difference between the Completion rate(% of total enrollments) of Israel and Completion rate(% of total enrollments) of Slovenia?
Provide a short and direct response. 5.08. In the year 2012, what is the difference between the Completion rate(% of total enrollments) in Latin America(all income levels) and Completion rate(% of total enrollments) in Burkina Faso?
Your answer should be very brief. 42.77. In the year 2012, what is the difference between the Completion rate(% of total enrollments) of Latin America(all income levels) and Completion rate(% of total enrollments) of Israel?
Offer a very short reply. -5.71. In the year 2012, what is the difference between the Completion rate(% of total enrollments) of Latin America(all income levels) and Completion rate(% of total enrollments) of Slovenia?
Provide a succinct answer. -0.51. In the year 2012, what is the difference between the Completion rate(% of total enrollments) in Burkina Faso and Completion rate(% of total enrollments) in Israel?
Ensure brevity in your answer.  -48.48. In the year 2012, what is the difference between the Completion rate(% of total enrollments) in Burkina Faso and Completion rate(% of total enrollments) in Slovenia?
Your response must be concise. -43.28. In the year 2012, what is the difference between the Completion rate(% of total enrollments) in Israel and Completion rate(% of total enrollments) in Slovenia?
Your answer should be very brief. 5.2. In the year 2013, what is the difference between the Completion rate(% of total enrollments) of Latin America(all income levels) and Completion rate(% of total enrollments) of Burkina Faso?
Your response must be concise. 38.21. In the year 2013, what is the difference between the Completion rate(% of total enrollments) of Latin America(all income levels) and Completion rate(% of total enrollments) of Israel?
Offer a very short reply. -1.08. In the year 2013, what is the difference between the Completion rate(% of total enrollments) of Latin America(all income levels) and Completion rate(% of total enrollments) of Slovenia?
Keep it short and to the point. 2.79. In the year 2013, what is the difference between the Completion rate(% of total enrollments) in Burkina Faso and Completion rate(% of total enrollments) in Israel?
Offer a very short reply. -39.3. In the year 2013, what is the difference between the Completion rate(% of total enrollments) of Burkina Faso and Completion rate(% of total enrollments) of Slovenia?
Keep it short and to the point. -35.42. In the year 2013, what is the difference between the Completion rate(% of total enrollments) in Israel and Completion rate(% of total enrollments) in Slovenia?
Your answer should be compact. 3.88. What is the ratio of the Completion rate(% of total enrollments) in Burkina Faso in 2002 to that in 2003?
Make the answer very short. 0.94. What is the ratio of the Completion rate(% of total enrollments) of Israel in 2002 to that in 2003?
Provide a short and direct response. 1. What is the ratio of the Completion rate(% of total enrollments) in Slovenia in 2002 to that in 2003?
Your answer should be compact. 0.95. What is the ratio of the Completion rate(% of total enrollments) of Burkina Faso in 2002 to that in 2004?
Provide a short and direct response. 0.9. What is the ratio of the Completion rate(% of total enrollments) in Israel in 2002 to that in 2004?
Make the answer very short. 0.97. What is the ratio of the Completion rate(% of total enrollments) of Slovenia in 2002 to that in 2004?
Ensure brevity in your answer.  0.86. What is the ratio of the Completion rate(% of total enrollments) in Latin America(all income levels) in 2002 to that in 2008?
Keep it short and to the point. 0.97. What is the ratio of the Completion rate(% of total enrollments) in Burkina Faso in 2002 to that in 2008?
Ensure brevity in your answer.  0.71. What is the ratio of the Completion rate(% of total enrollments) in Israel in 2002 to that in 2008?
Provide a short and direct response. 1.04. What is the ratio of the Completion rate(% of total enrollments) of Slovenia in 2002 to that in 2008?
Offer a terse response. 1. What is the ratio of the Completion rate(% of total enrollments) of Burkina Faso in 2002 to that in 2009?
Ensure brevity in your answer.  0.63. What is the ratio of the Completion rate(% of total enrollments) of Israel in 2002 to that in 2009?
Give a very brief answer. 1.01. What is the ratio of the Completion rate(% of total enrollments) of Slovenia in 2002 to that in 2009?
Offer a very short reply. 1.01. What is the ratio of the Completion rate(% of total enrollments) of Latin America(all income levels) in 2002 to that in 2010?
Provide a short and direct response. 0.97. What is the ratio of the Completion rate(% of total enrollments) of Burkina Faso in 2002 to that in 2010?
Your answer should be compact. 0.58. What is the ratio of the Completion rate(% of total enrollments) of Israel in 2002 to that in 2010?
Ensure brevity in your answer.  1.03. What is the ratio of the Completion rate(% of total enrollments) of Slovenia in 2002 to that in 2010?
Give a very brief answer. 1. What is the ratio of the Completion rate(% of total enrollments) in Latin America(all income levels) in 2002 to that in 2012?
Provide a succinct answer. 0.96. What is the ratio of the Completion rate(% of total enrollments) in Burkina Faso in 2002 to that in 2012?
Your answer should be compact. 0.48. What is the ratio of the Completion rate(% of total enrollments) in Israel in 2002 to that in 2012?
Offer a very short reply. 0.98. What is the ratio of the Completion rate(% of total enrollments) in Slovenia in 2002 to that in 2012?
Offer a terse response. 0.95. What is the ratio of the Completion rate(% of total enrollments) of Latin America(all income levels) in 2002 to that in 2013?
Ensure brevity in your answer.  0.95. What is the ratio of the Completion rate(% of total enrollments) in Burkina Faso in 2002 to that in 2013?
Provide a short and direct response. 0.44. What is the ratio of the Completion rate(% of total enrollments) of Israel in 2002 to that in 2013?
Ensure brevity in your answer.  1.02. What is the ratio of the Completion rate(% of total enrollments) of Slovenia in 2002 to that in 2013?
Offer a very short reply. 0.98. What is the ratio of the Completion rate(% of total enrollments) of Latin America(all income levels) in 2003 to that in 2004?
Keep it short and to the point. 1. What is the ratio of the Completion rate(% of total enrollments) of Burkina Faso in 2003 to that in 2004?
Ensure brevity in your answer.  0.96. What is the ratio of the Completion rate(% of total enrollments) of Israel in 2003 to that in 2004?
Keep it short and to the point. 0.97. What is the ratio of the Completion rate(% of total enrollments) in Slovenia in 2003 to that in 2004?
Provide a succinct answer. 0.9. What is the ratio of the Completion rate(% of total enrollments) in Latin America(all income levels) in 2003 to that in 2008?
Provide a succinct answer. 0.97. What is the ratio of the Completion rate(% of total enrollments) in Burkina Faso in 2003 to that in 2008?
Provide a succinct answer. 0.75. What is the ratio of the Completion rate(% of total enrollments) of Israel in 2003 to that in 2008?
Offer a very short reply. 1.04. What is the ratio of the Completion rate(% of total enrollments) of Slovenia in 2003 to that in 2008?
Your response must be concise. 1.05. What is the ratio of the Completion rate(% of total enrollments) in Latin America(all income levels) in 2003 to that in 2009?
Your response must be concise. 0.97. What is the ratio of the Completion rate(% of total enrollments) in Burkina Faso in 2003 to that in 2009?
Provide a short and direct response. 0.66. What is the ratio of the Completion rate(% of total enrollments) in Israel in 2003 to that in 2009?
Your answer should be very brief. 1.01. What is the ratio of the Completion rate(% of total enrollments) in Slovenia in 2003 to that in 2009?
Keep it short and to the point. 1.06. What is the ratio of the Completion rate(% of total enrollments) of Latin America(all income levels) in 2003 to that in 2010?
Provide a succinct answer. 0.97. What is the ratio of the Completion rate(% of total enrollments) of Burkina Faso in 2003 to that in 2010?
Make the answer very short. 0.62. What is the ratio of the Completion rate(% of total enrollments) of Israel in 2003 to that in 2010?
Ensure brevity in your answer.  1.03. What is the ratio of the Completion rate(% of total enrollments) of Slovenia in 2003 to that in 2010?
Provide a succinct answer. 1.04. What is the ratio of the Completion rate(% of total enrollments) in Latin America(all income levels) in 2003 to that in 2012?
Make the answer very short. 0.96. What is the ratio of the Completion rate(% of total enrollments) in Burkina Faso in 2003 to that in 2012?
Give a very brief answer. 0.51. What is the ratio of the Completion rate(% of total enrollments) in Israel in 2003 to that in 2012?
Your response must be concise. 0.99. What is the ratio of the Completion rate(% of total enrollments) of Latin America(all income levels) in 2003 to that in 2013?
Provide a short and direct response. 0.95. What is the ratio of the Completion rate(% of total enrollments) in Burkina Faso in 2003 to that in 2013?
Your answer should be very brief. 0.46. What is the ratio of the Completion rate(% of total enrollments) in Israel in 2003 to that in 2013?
Your answer should be compact. 1.02. What is the ratio of the Completion rate(% of total enrollments) of Slovenia in 2003 to that in 2013?
Offer a very short reply. 1.03. What is the ratio of the Completion rate(% of total enrollments) in Latin America(all income levels) in 2004 to that in 2008?
Your response must be concise. 0.98. What is the ratio of the Completion rate(% of total enrollments) in Burkina Faso in 2004 to that in 2008?
Ensure brevity in your answer.  0.78. What is the ratio of the Completion rate(% of total enrollments) in Israel in 2004 to that in 2008?
Offer a very short reply. 1.08. What is the ratio of the Completion rate(% of total enrollments) of Slovenia in 2004 to that in 2008?
Keep it short and to the point. 1.17. What is the ratio of the Completion rate(% of total enrollments) in Latin America(all income levels) in 2004 to that in 2009?
Offer a very short reply. 0.98. What is the ratio of the Completion rate(% of total enrollments) in Burkina Faso in 2004 to that in 2009?
Your answer should be compact. 0.69. What is the ratio of the Completion rate(% of total enrollments) in Israel in 2004 to that in 2009?
Ensure brevity in your answer.  1.05. What is the ratio of the Completion rate(% of total enrollments) of Slovenia in 2004 to that in 2009?
Your response must be concise. 1.18. What is the ratio of the Completion rate(% of total enrollments) of Latin America(all income levels) in 2004 to that in 2010?
Offer a terse response. 0.98. What is the ratio of the Completion rate(% of total enrollments) of Burkina Faso in 2004 to that in 2010?
Provide a short and direct response. 0.65. What is the ratio of the Completion rate(% of total enrollments) of Israel in 2004 to that in 2010?
Your answer should be very brief. 1.06. What is the ratio of the Completion rate(% of total enrollments) in Slovenia in 2004 to that in 2010?
Make the answer very short. 1.16. What is the ratio of the Completion rate(% of total enrollments) of Latin America(all income levels) in 2004 to that in 2012?
Offer a terse response. 0.96. What is the ratio of the Completion rate(% of total enrollments) in Burkina Faso in 2004 to that in 2012?
Your answer should be compact. 0.53. What is the ratio of the Completion rate(% of total enrollments) of Israel in 2004 to that in 2012?
Your response must be concise. 1.02. What is the ratio of the Completion rate(% of total enrollments) in Slovenia in 2004 to that in 2012?
Your answer should be very brief. 1.11. What is the ratio of the Completion rate(% of total enrollments) in Latin America(all income levels) in 2004 to that in 2013?
Keep it short and to the point. 0.96. What is the ratio of the Completion rate(% of total enrollments) of Burkina Faso in 2004 to that in 2013?
Your answer should be very brief. 0.48. What is the ratio of the Completion rate(% of total enrollments) in Israel in 2004 to that in 2013?
Provide a short and direct response. 1.06. What is the ratio of the Completion rate(% of total enrollments) of Slovenia in 2004 to that in 2013?
Offer a very short reply. 1.14. What is the ratio of the Completion rate(% of total enrollments) in Burkina Faso in 2008 to that in 2009?
Offer a terse response. 0.89. What is the ratio of the Completion rate(% of total enrollments) in Israel in 2008 to that in 2009?
Your answer should be compact. 0.97. What is the ratio of the Completion rate(% of total enrollments) of Slovenia in 2008 to that in 2009?
Provide a succinct answer. 1.01. What is the ratio of the Completion rate(% of total enrollments) of Burkina Faso in 2008 to that in 2010?
Ensure brevity in your answer.  0.83. What is the ratio of the Completion rate(% of total enrollments) of Israel in 2008 to that in 2010?
Ensure brevity in your answer.  0.99. What is the ratio of the Completion rate(% of total enrollments) of Slovenia in 2008 to that in 2010?
Ensure brevity in your answer.  0.99. What is the ratio of the Completion rate(% of total enrollments) of Latin America(all income levels) in 2008 to that in 2012?
Provide a short and direct response. 0.98. What is the ratio of the Completion rate(% of total enrollments) in Burkina Faso in 2008 to that in 2012?
Ensure brevity in your answer.  0.67. What is the ratio of the Completion rate(% of total enrollments) in Israel in 2008 to that in 2012?
Your answer should be compact. 0.94. What is the ratio of the Completion rate(% of total enrollments) of Slovenia in 2008 to that in 2012?
Provide a short and direct response. 0.95. What is the ratio of the Completion rate(% of total enrollments) of Latin America(all income levels) in 2008 to that in 2013?
Offer a terse response. 0.98. What is the ratio of the Completion rate(% of total enrollments) of Burkina Faso in 2008 to that in 2013?
Ensure brevity in your answer.  0.62. What is the ratio of the Completion rate(% of total enrollments) of Israel in 2008 to that in 2013?
Provide a short and direct response. 0.98. What is the ratio of the Completion rate(% of total enrollments) in Latin America(all income levels) in 2009 to that in 2010?
Ensure brevity in your answer.  1. What is the ratio of the Completion rate(% of total enrollments) of Burkina Faso in 2009 to that in 2010?
Your answer should be compact. 0.93. What is the ratio of the Completion rate(% of total enrollments) of Israel in 2009 to that in 2010?
Ensure brevity in your answer.  1.02. What is the ratio of the Completion rate(% of total enrollments) of Latin America(all income levels) in 2009 to that in 2012?
Offer a very short reply. 0.98. What is the ratio of the Completion rate(% of total enrollments) in Burkina Faso in 2009 to that in 2012?
Your answer should be very brief. 0.76. What is the ratio of the Completion rate(% of total enrollments) of Israel in 2009 to that in 2012?
Provide a succinct answer. 0.97. What is the ratio of the Completion rate(% of total enrollments) in Slovenia in 2009 to that in 2012?
Make the answer very short. 0.94. What is the ratio of the Completion rate(% of total enrollments) in Latin America(all income levels) in 2009 to that in 2013?
Offer a very short reply. 0.98. What is the ratio of the Completion rate(% of total enrollments) of Burkina Faso in 2009 to that in 2013?
Keep it short and to the point. 0.7. What is the ratio of the Completion rate(% of total enrollments) of Israel in 2009 to that in 2013?
Provide a succinct answer. 1.01. What is the ratio of the Completion rate(% of total enrollments) in Slovenia in 2009 to that in 2013?
Offer a very short reply. 0.97. What is the ratio of the Completion rate(% of total enrollments) of Latin America(all income levels) in 2010 to that in 2012?
Provide a succinct answer. 0.98. What is the ratio of the Completion rate(% of total enrollments) of Burkina Faso in 2010 to that in 2012?
Your answer should be compact. 0.82. What is the ratio of the Completion rate(% of total enrollments) of Israel in 2010 to that in 2012?
Ensure brevity in your answer.  0.96. What is the ratio of the Completion rate(% of total enrollments) in Slovenia in 2010 to that in 2012?
Your response must be concise. 0.96. What is the ratio of the Completion rate(% of total enrollments) of Latin America(all income levels) in 2010 to that in 2013?
Make the answer very short. 0.98. What is the ratio of the Completion rate(% of total enrollments) of Burkina Faso in 2010 to that in 2013?
Make the answer very short. 0.75. What is the ratio of the Completion rate(% of total enrollments) in Slovenia in 2010 to that in 2013?
Ensure brevity in your answer.  0.98. What is the ratio of the Completion rate(% of total enrollments) of Burkina Faso in 2012 to that in 2013?
Provide a succinct answer. 0.92. What is the ratio of the Completion rate(% of total enrollments) in Israel in 2012 to that in 2013?
Your answer should be compact. 1.04. What is the ratio of the Completion rate(% of total enrollments) in Slovenia in 2012 to that in 2013?
Your response must be concise. 1.03. What is the difference between the highest and the second highest Completion rate(% of total enrollments) of Latin America(all income levels)?
Keep it short and to the point. 0.59. What is the difference between the highest and the second highest Completion rate(% of total enrollments) in Burkina Faso?
Give a very brief answer. 5.15. What is the difference between the highest and the second highest Completion rate(% of total enrollments) in Israel?
Your answer should be very brief. 2.06. What is the difference between the highest and the second highest Completion rate(% of total enrollments) of Slovenia?
Offer a terse response. 11.22. What is the difference between the highest and the lowest Completion rate(% of total enrollments) of Latin America(all income levels)?
Ensure brevity in your answer.  4.67. What is the difference between the highest and the lowest Completion rate(% of total enrollments) of Burkina Faso?
Provide a succinct answer. 35.27. What is the difference between the highest and the lowest Completion rate(% of total enrollments) of Israel?
Your response must be concise. 7.94. What is the difference between the highest and the lowest Completion rate(% of total enrollments) in Slovenia?
Offer a terse response. 17.04. 